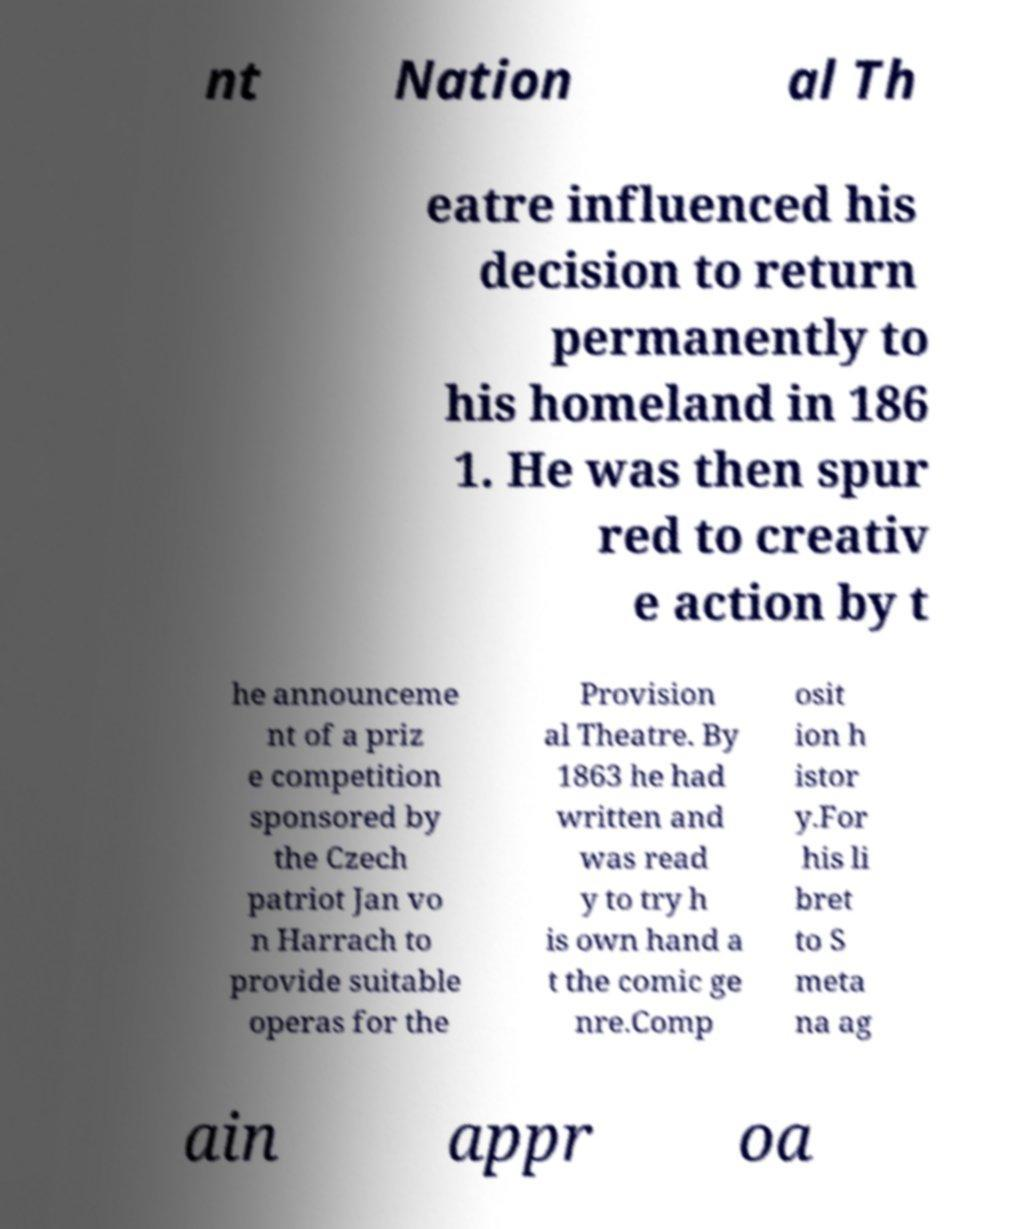For documentation purposes, I need the text within this image transcribed. Could you provide that? nt Nation al Th eatre influenced his decision to return permanently to his homeland in 186 1. He was then spur red to creativ e action by t he announceme nt of a priz e competition sponsored by the Czech patriot Jan vo n Harrach to provide suitable operas for the Provision al Theatre. By 1863 he had written and was read y to try h is own hand a t the comic ge nre.Comp osit ion h istor y.For his li bret to S meta na ag ain appr oa 